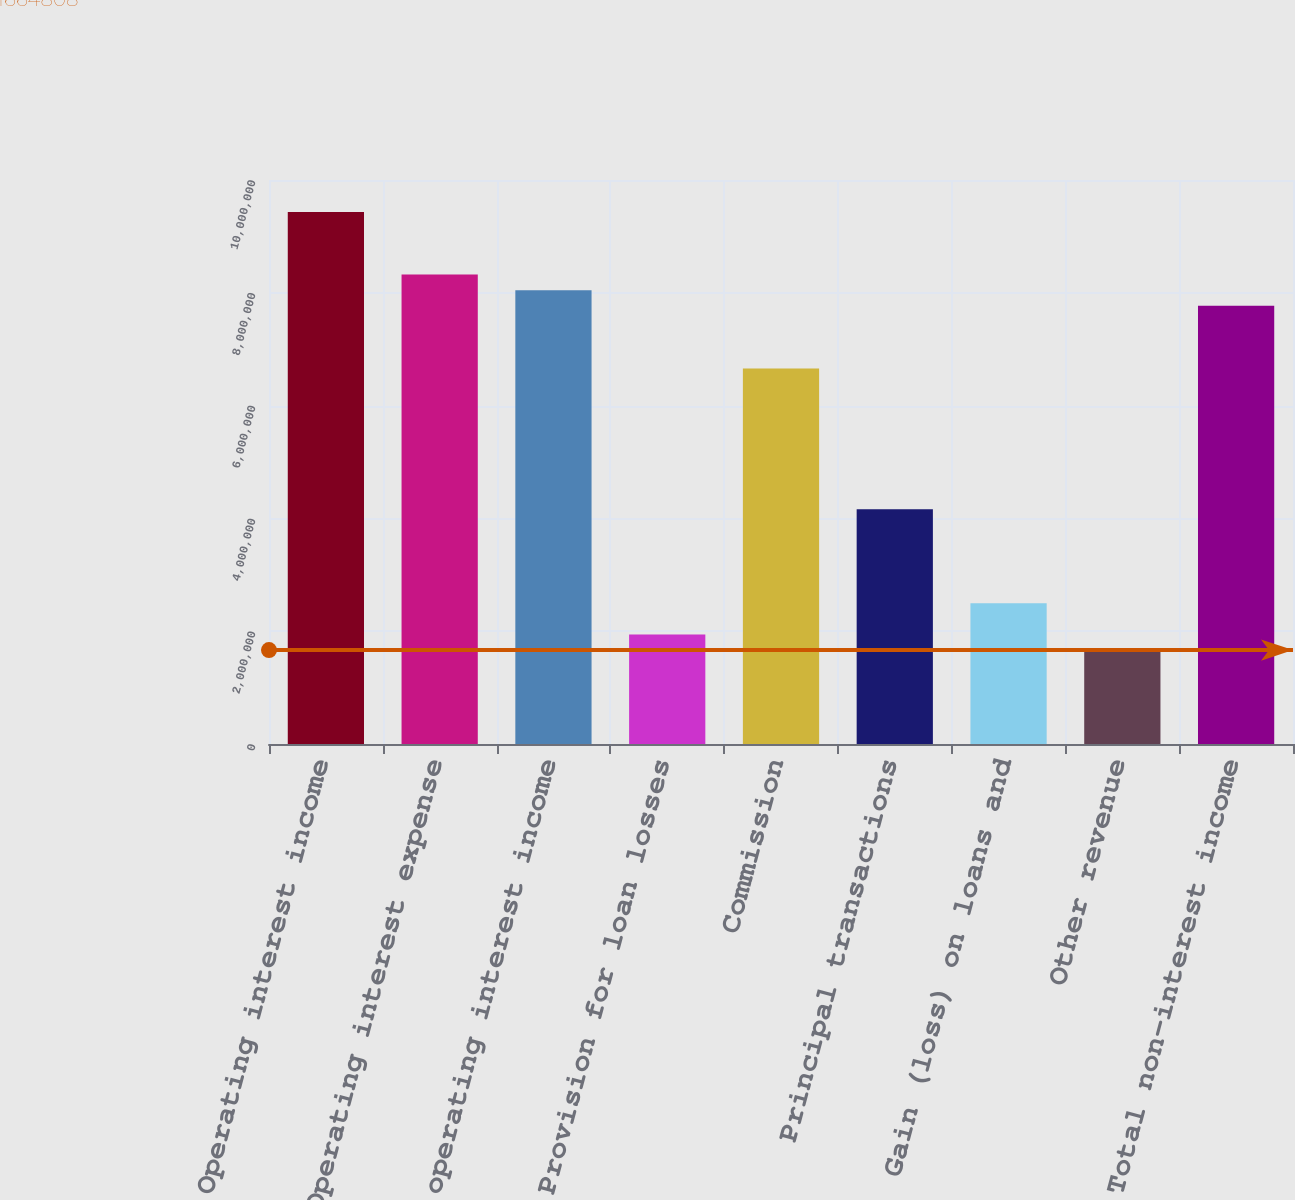Convert chart to OTSL. <chart><loc_0><loc_0><loc_500><loc_500><bar_chart><fcel>Operating interest income<fcel>Operating interest expense<fcel>Net operating interest income<fcel>Provision for loan losses<fcel>Commission<fcel>Principal transactions<fcel>Gain (loss) on loans and<fcel>Other revenue<fcel>Total non-interest income<nl><fcel>9.43391e+06<fcel>8.32403e+06<fcel>8.04657e+06<fcel>1.94228e+06<fcel>6.65923e+06<fcel>4.16202e+06<fcel>2.49721e+06<fcel>1.66481e+06<fcel>7.7691e+06<nl></chart> 